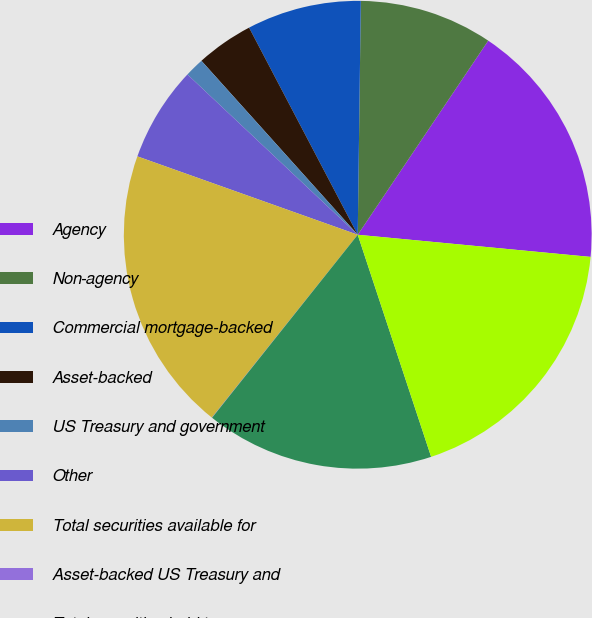Convert chart to OTSL. <chart><loc_0><loc_0><loc_500><loc_500><pie_chart><fcel>Agency<fcel>Non-agency<fcel>Commercial mortgage-backed<fcel>Asset-backed<fcel>US Treasury and government<fcel>Other<fcel>Total securities available for<fcel>Asset-backed US Treasury and<fcel>Total securities held to<fcel>Residential real estate<nl><fcel>17.09%<fcel>9.21%<fcel>7.9%<fcel>3.96%<fcel>1.33%<fcel>6.58%<fcel>19.72%<fcel>0.02%<fcel>15.78%<fcel>18.41%<nl></chart> 